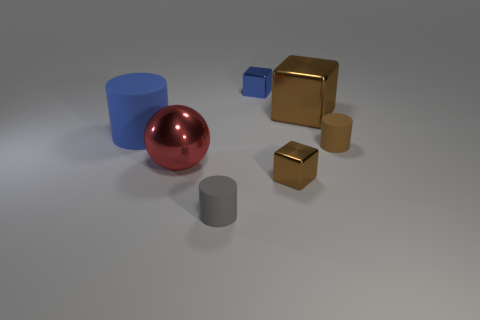Add 2 metallic objects. How many objects exist? 9 Subtract all cubes. How many objects are left? 4 Subtract all gray rubber cylinders. Subtract all large blue rubber objects. How many objects are left? 5 Add 5 small brown cylinders. How many small brown cylinders are left? 6 Add 3 big cubes. How many big cubes exist? 4 Subtract 0 cyan cylinders. How many objects are left? 7 